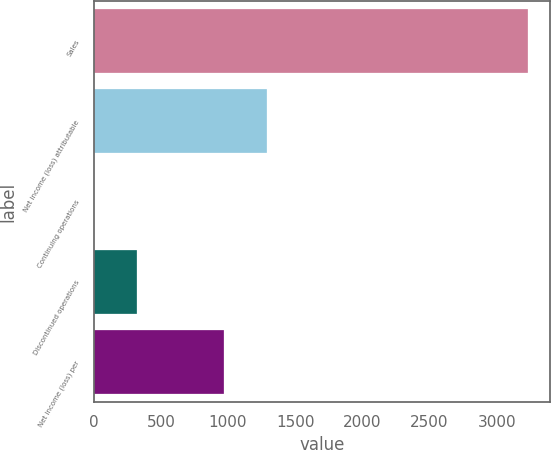Convert chart. <chart><loc_0><loc_0><loc_500><loc_500><bar_chart><fcel>Sales<fcel>Net income (loss) attributable<fcel>Continuing operations<fcel>Discontinued operations<fcel>Net income (loss) per<nl><fcel>3234<fcel>1293.64<fcel>0.08<fcel>323.47<fcel>970.25<nl></chart> 